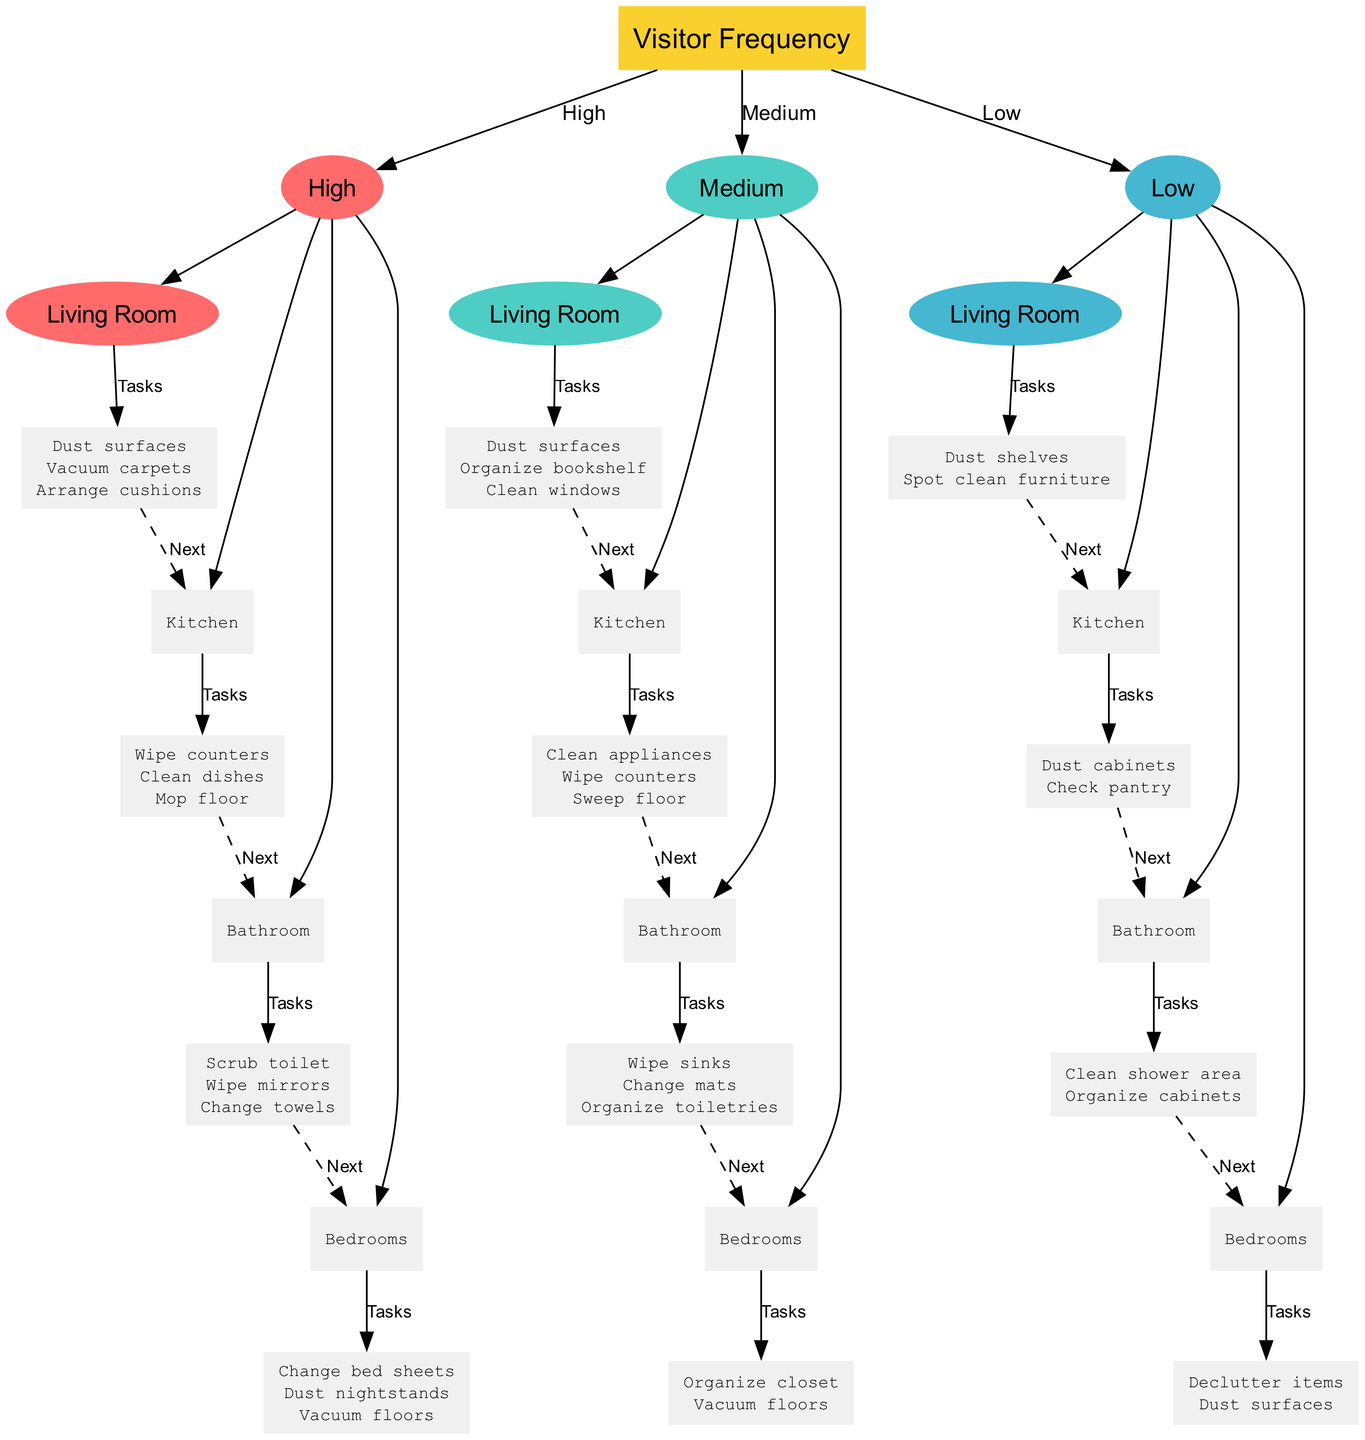What is the root node of this decision tree? The root node is labeled "Visitor Frequency," indicating that the first level of decision-making revolves around how often visitors come.
Answer: Visitor Frequency How many main branches are there from the root node? There are three main branches: High, Medium, and Low, which categorize the visitor frequency into these three levels.
Answer: 3 What tasks are associated with the High frequency Living Room? The tasks for the High frequency Living Room include "Dust surfaces," "Vacuum carpets," and "Arrange cushions."
Answer: Dust surfaces, Vacuum carpets, Arrange cushions Which room has a cleaning task to "Organize toiletries" when the visitor frequency is Medium? The room with the task "Organize toiletries" under Medium frequency is the Bathroom.
Answer: Bathroom If a giving frequency is Low, what is the last room to process before reaching "Done"? The last room to process before reaching "Done" at Low frequency is the Bedrooms.
Answer: Bedrooms What is the second task in the cleaning schedule for the Kitchen when visitors are High? The second task in the High frequency Kitchen is "Clean dishes."
Answer: Clean dishes If a visitor comes with Low frequency, what is the task to be done in the Bathroom? In the Bathroom, the tasks at Low frequency include "Clean shower area" and "Organize cabinets," but since the question asks specifically for one, the first mentioned is also the answer.
Answer: Clean shower area How does the flow proceed after the tasks for the Bedrooms at Medium frequency? After completing the tasks for the Bedrooms at Medium frequency, the flow proceeds to "Done" without any more steps.
Answer: Done What color represents the branches in this diagram for High frequency tasks? The color representing the branches under High frequency tasks is a shade of red, which is indicated as #FF6B6B.
Answer: #FF6B6B 